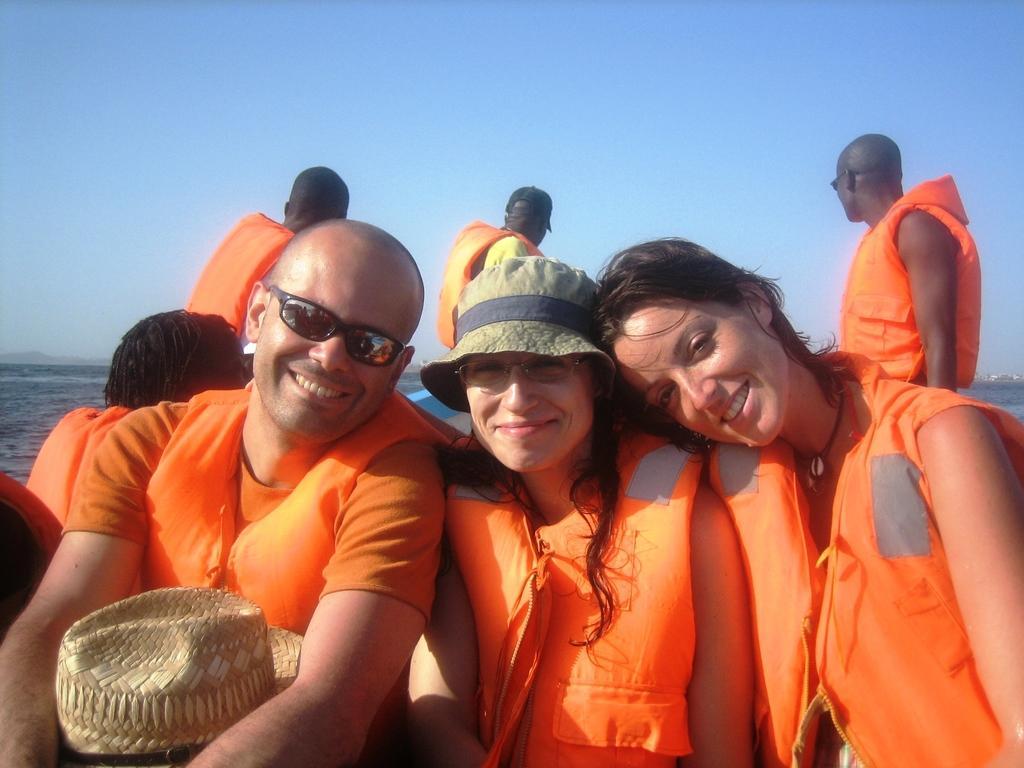Please provide a concise description of this image. In the image there is a man and two women in orange life jacket sitting in the front and smiling and behind them there are few persons sitting in the boat and over the back it seems to be ocean on the left side and above its sky. 